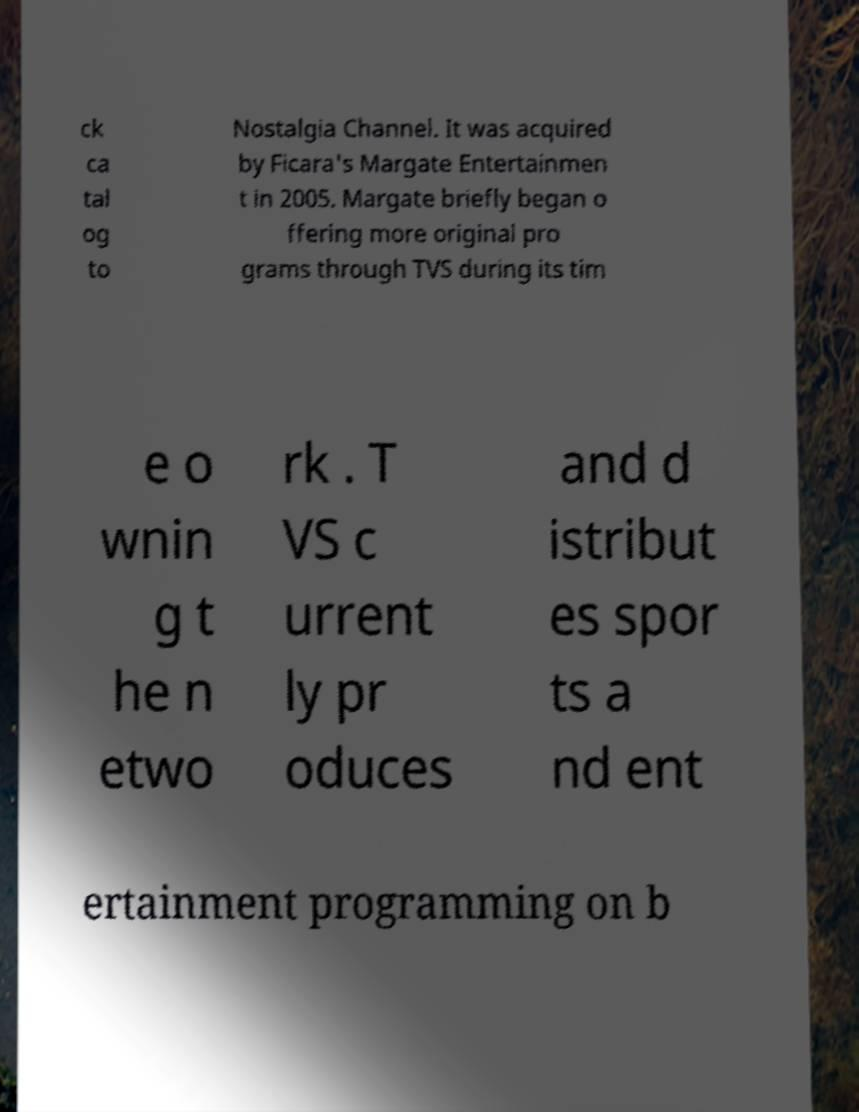Please read and relay the text visible in this image. What does it say? ck ca tal og to Nostalgia Channel. It was acquired by Ficara's Margate Entertainmen t in 2005. Margate briefly began o ffering more original pro grams through TVS during its tim e o wnin g t he n etwo rk . T VS c urrent ly pr oduces and d istribut es spor ts a nd ent ertainment programming on b 